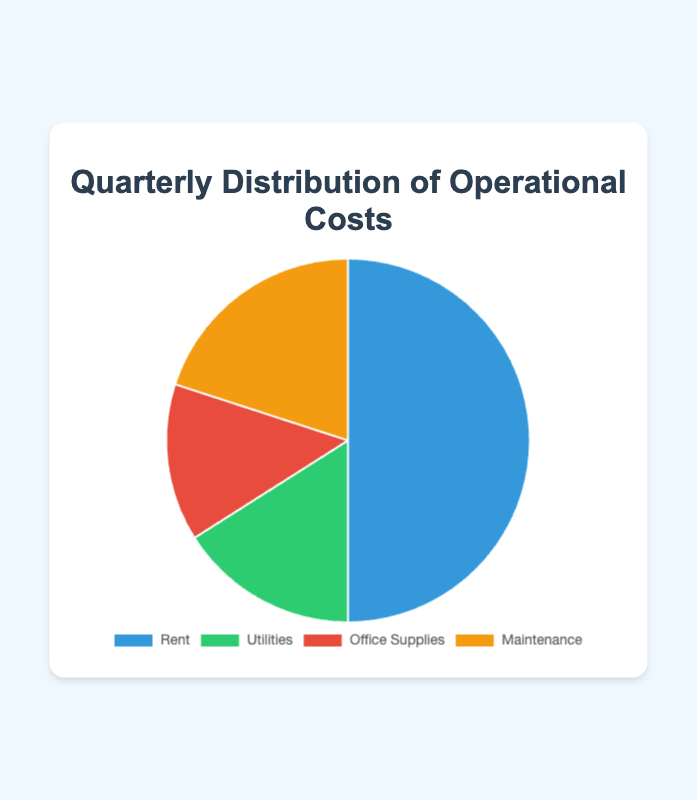What percentage of the total operational costs is spent on maintenance and office supplies combined? Add the percentages for maintenance (20%) and office supplies (14%). 20% + 14% = 34%.
Answer: 34% Which category has the lowest operational cost? Compare the 'Amount' values for all categories. Utilities have the smallest amount, which is $8000.
Answer: Utilities By how much is the rent cost greater than the maintenance cost? Subtract the maintenance amount ($10000) from the rent amount ($25000). $25000 - $10000 = $15000.
Answer: $15000 Which category has the largest share in the pie chart? Identify the category with the highest percentage. Rent has the largest share, which is 50%.
Answer: Rent What is the combined cost of rent and utilities? Add the amounts for rent ($25000) and utilities ($8000). $25000 + $8000 = $33000.
Answer: $33000 Which two categories together account for more than half of the operational costs? Add up percentages of each pair to see which sum is greater than 50%. Rent (50%) and any other category would be more than half. Rent and any category work, but the smallest sum would be rent and utilities.
Answer: Rent and any other category What is the difference in percentage points between the highest and the lowest category costs? Subtract the percentage of the lowest category (Utilities, 16%) from the highest category (Rent, 50%). 50% - 16% = 34%.
Answer: 34% What is the total cost allocated for utilities and office supplies? Add the amounts for utilities ($8000) and office supplies ($7000). $8000 + $7000 = $15000.
Answer: $15000 Which color represents the office supplies category in the pie chart? Identify the visual attribute from the chart. Office supplies are represented by a red color slice.
Answer: Red 